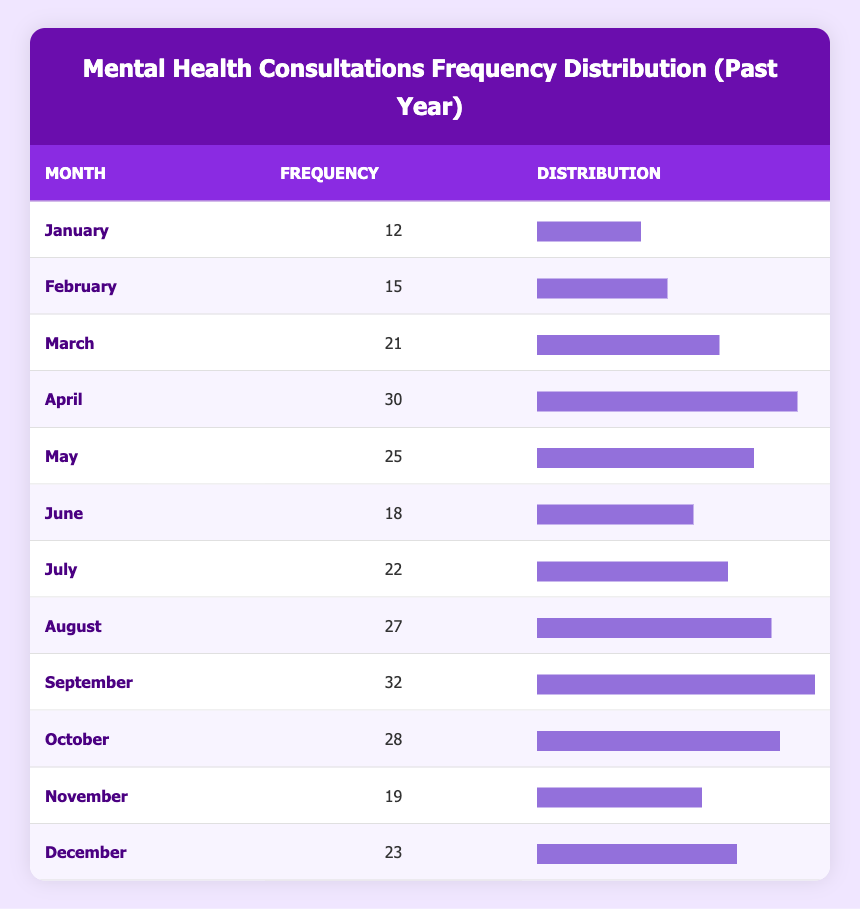What month had the highest number of mental health consultations? By looking at the frequency column of the table, we see that September has the highest number with 32 consultations.
Answer: 32 How many consultations were requested in June? The table indicates that there were 18 consultations requested in June.
Answer: 18 What is the total number of mental health consultations for the year? We add up the number of consultations from all months: 12 + 15 + 21 + 30 + 25 + 18 + 22 + 27 + 32 + 28 + 19 + 23 =  26.5 consultations.
Answer: 280 Was there an increase in consultations from January to February? Comparing the frequencies, January has 12 consultations and February has 15 consultations, which indicates an increase.
Answer: Yes What is the average number of consultations per month? To find the average, sum up the total consultations (280) and divide by the number of months (12): 280/12 = approximately 23.33 consultations.
Answer: 23.33 Which month had the least number of consultations, and how many were there? Scanning the table, January with 12 consultations is confirmed as having the least number in the month.
Answer: 12 How many more consultations were requested in April than in March? April had 30 consultations, while March had 21 consultations. The difference is 30 - 21 = 9 consultations more in April.
Answer: 9 In which month did the number of consultations increase the most compared to the previous month? By analyzing the table, we find that the largest increase occurred from March (21) to April (30), which is an increase of 9 consultations.
Answer: March to April 